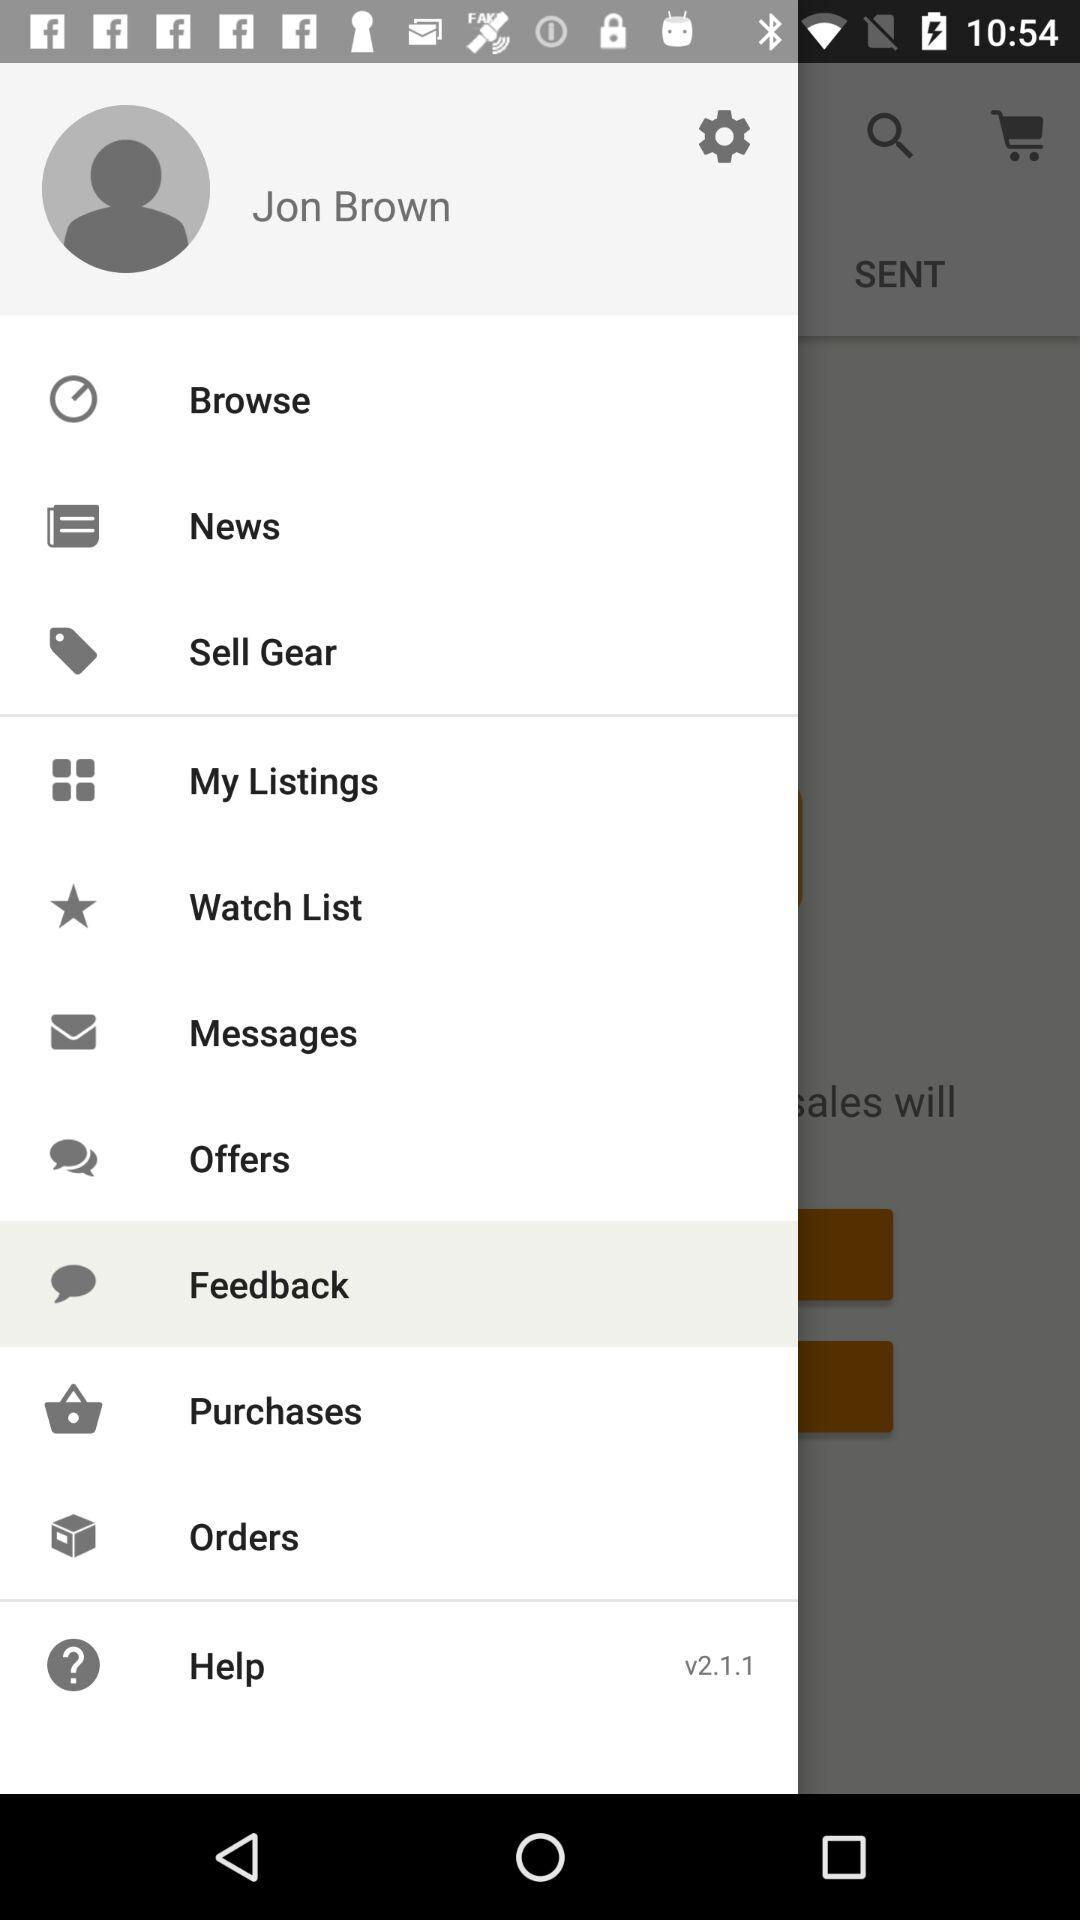What is the user name? The user name is Jon Brown. 